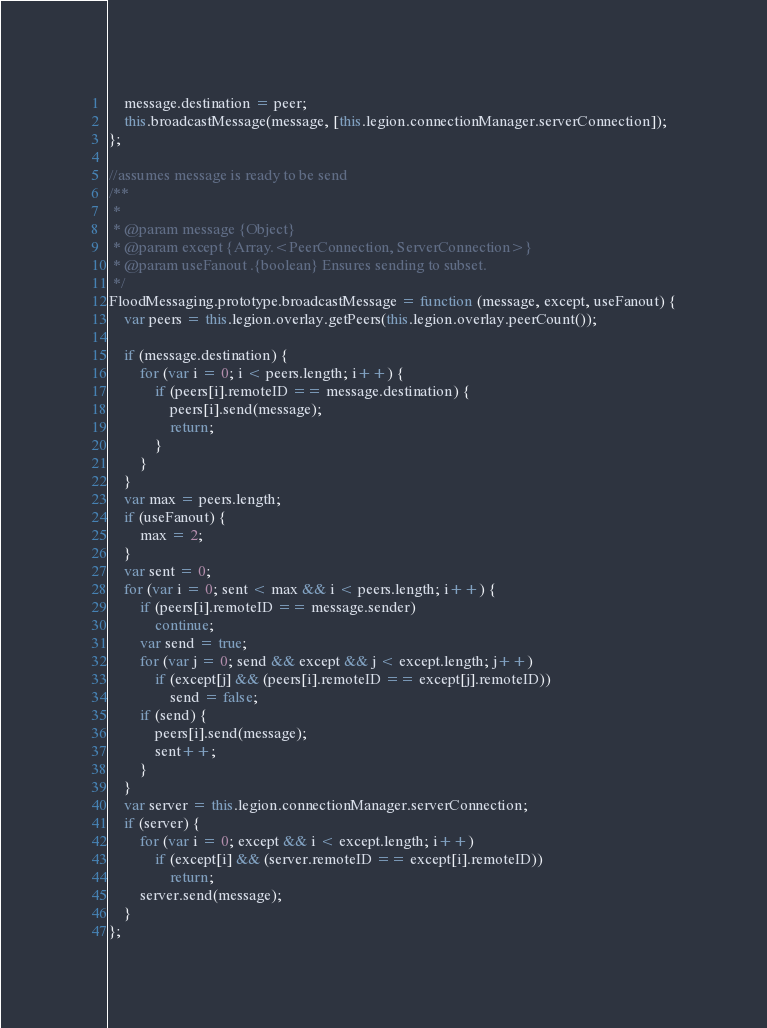Convert code to text. <code><loc_0><loc_0><loc_500><loc_500><_JavaScript_>    message.destination = peer;
    this.broadcastMessage(message, [this.legion.connectionManager.serverConnection]);
};

//assumes message is ready to be send
/**
 *
 * @param message {Object}
 * @param except {Array.<PeerConnection, ServerConnection>}
 * @param useFanout .{boolean} Ensures sending to subset.
 */
FloodMessaging.prototype.broadcastMessage = function (message, except, useFanout) {
    var peers = this.legion.overlay.getPeers(this.legion.overlay.peerCount());

    if (message.destination) {
        for (var i = 0; i < peers.length; i++) {
            if (peers[i].remoteID == message.destination) {
                peers[i].send(message);
                return;
            }
        }
    }
    var max = peers.length;
    if (useFanout) {
        max = 2;
    }
    var sent = 0;
    for (var i = 0; sent < max && i < peers.length; i++) {
        if (peers[i].remoteID == message.sender)
            continue;
        var send = true;
        for (var j = 0; send && except && j < except.length; j++)
            if (except[j] && (peers[i].remoteID == except[j].remoteID))
                send = false;
        if (send) {
            peers[i].send(message);
            sent++;
        }
    }
    var server = this.legion.connectionManager.serverConnection;
    if (server) {
        for (var i = 0; except && i < except.length; i++)
            if (except[i] && (server.remoteID == except[i].remoteID))
                return;
        server.send(message);
    }
};</code> 